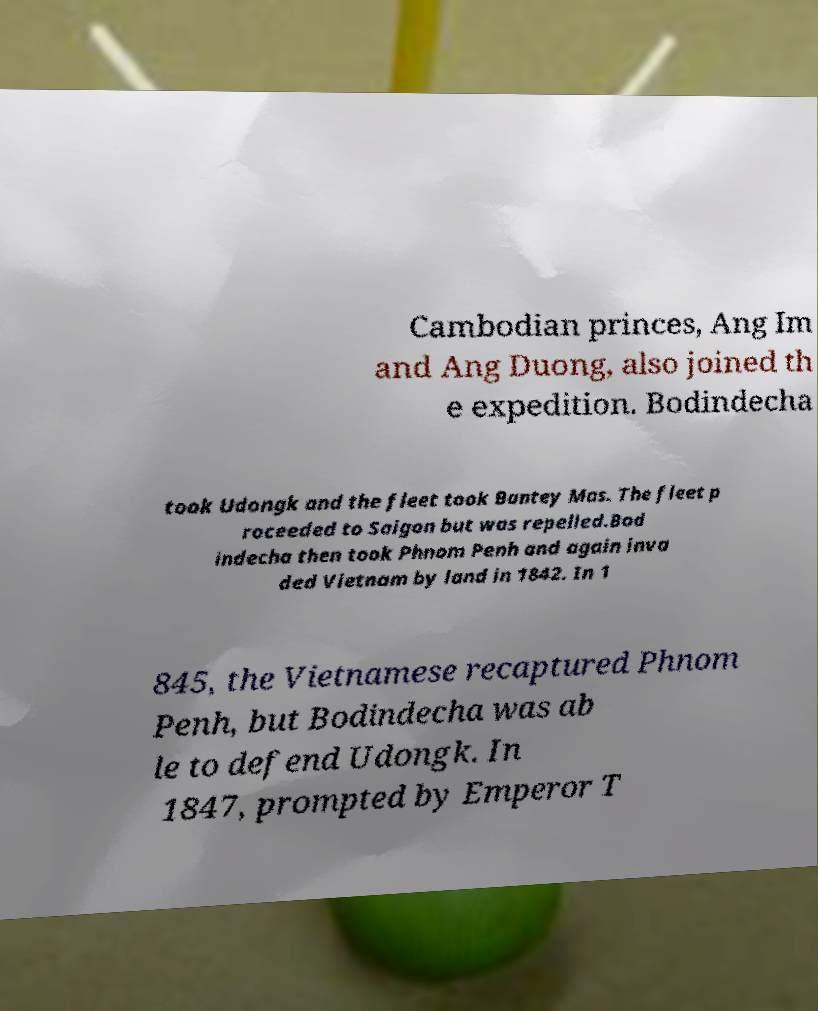Please identify and transcribe the text found in this image. Cambodian princes, Ang Im and Ang Duong, also joined th e expedition. Bodindecha took Udongk and the fleet took Bantey Mas. The fleet p roceeded to Saigon but was repelled.Bod indecha then took Phnom Penh and again inva ded Vietnam by land in 1842. In 1 845, the Vietnamese recaptured Phnom Penh, but Bodindecha was ab le to defend Udongk. In 1847, prompted by Emperor T 